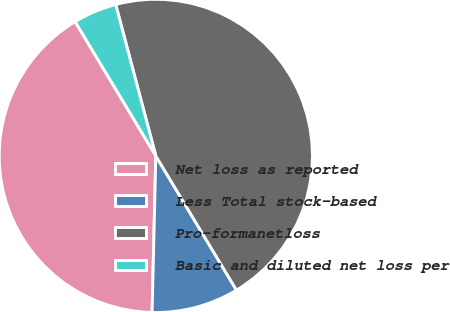Convert chart. <chart><loc_0><loc_0><loc_500><loc_500><pie_chart><fcel>Net loss as reported<fcel>Less Total stock-based<fcel>Pro-formanetloss<fcel>Basic and diluted net loss per<nl><fcel>41.01%<fcel>8.99%<fcel>45.51%<fcel>4.49%<nl></chart> 